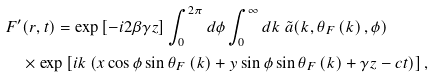Convert formula to latex. <formula><loc_0><loc_0><loc_500><loc_500>& F ^ { \prime } ( r , t ) = \exp \left [ - i 2 \beta \gamma z \right ] \int _ { 0 } ^ { 2 \pi } d \phi \int _ { 0 } ^ { \infty } d k \ \tilde { a } ( k , \theta _ { F } \left ( k \right ) , \phi ) \\ & \quad \times \exp \left [ i k \left ( x \cos \phi \sin \theta _ { F } \left ( k \right ) + y \sin \phi \sin \theta _ { F } \left ( k \right ) + \gamma z - c t \right ) \right ] \text {,}</formula> 